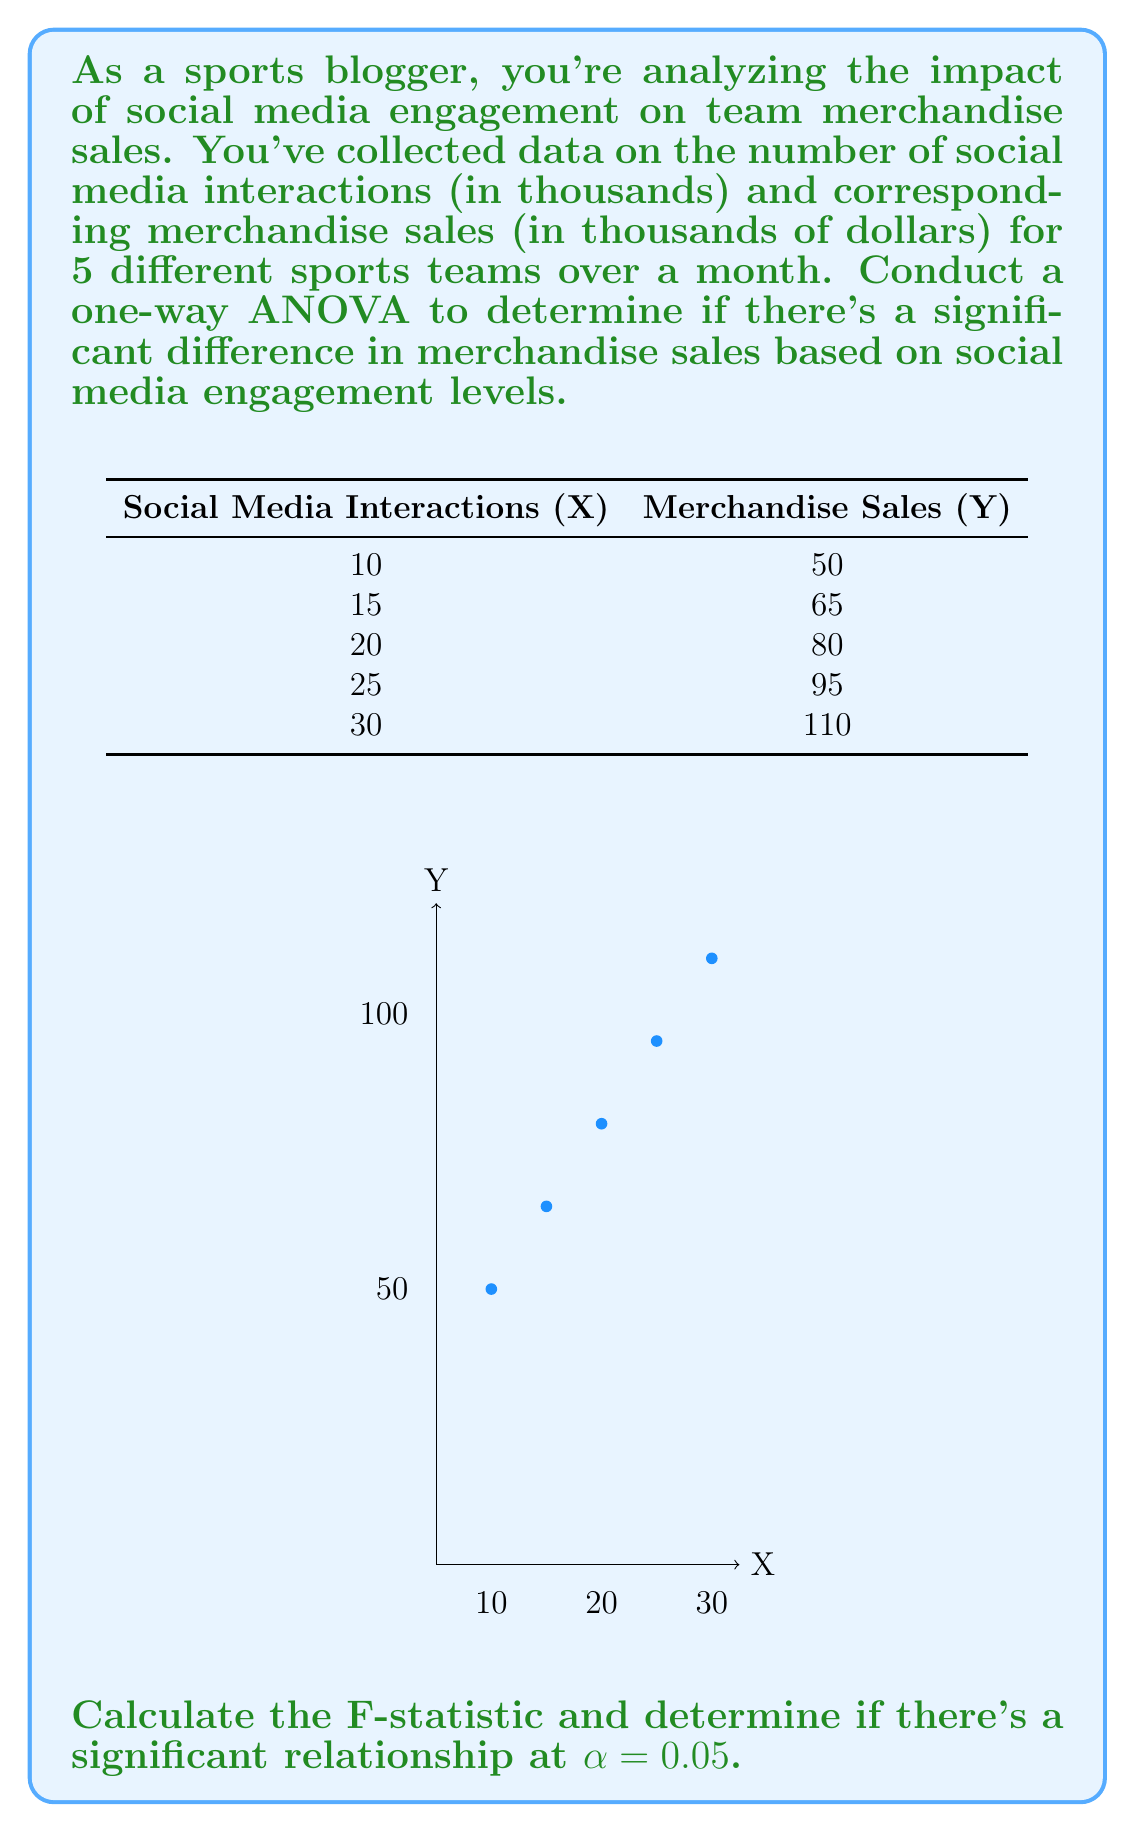Can you answer this question? To conduct a one-way ANOVA, we'll follow these steps:

1) Calculate the total sum of squares (SST):
   $$SST = \sum (Y_i - \bar{Y})^2$$
   where $\bar{Y}$ is the mean of all Y values.

2) Calculate the regression sum of squares (SSR):
   $$SSR = \sum n_i(\bar{Y_i} - \bar{Y})^2$$
   where $\bar{Y_i}$ is the mean of Y for each X value, and $n_i$ is the number of observations for each X (here, always 1).

3) Calculate the error sum of squares (SSE):
   $$SSE = SST - SSR$$

4) Calculate the degrees of freedom:
   $$df_{total} = n - 1 = 5 - 1 = 4$$
   $$df_{between} = k - 1 = 5 - 1 = 4$$ (k is the number of X values)
   $$df_{within} = n - k = 5 - 5 = 0$$

5) Calculate the mean square for regression (MSR) and error (MSE):
   $$MSR = \frac{SSR}{df_{between}}$$
   $$MSE = \frac{SSE}{df_{within}}$$ (Note: MSE is undefined here as $df_{within} = 0$)

6) Calculate the F-statistic:
   $$F = \frac{MSR}{MSE}$$

Calculations:
$\bar{Y} = 80$

SST = $(50-80)^2 + (65-80)^2 + (80-80)^2 + (95-80)^2 + (110-80)^2 = 2350$

SSR = $1(50-80)^2 + 1(65-80)^2 + 1(80-80)^2 + 1(95-80)^2 + 1(110-80)^2 = 2350$

SSE = SST - SSR = 2350 - 2350 = 0

MSR = 2350 / 4 = 587.5

As SSE = 0 and $df_{within} = 0$, MSE is undefined, and we cannot calculate the F-statistic.

This perfect fit indicates that there's a deterministic linear relationship between social media interactions and merchandise sales in this data set.
Answer: Perfect linear relationship; F-statistic undefined due to zero error variance. 